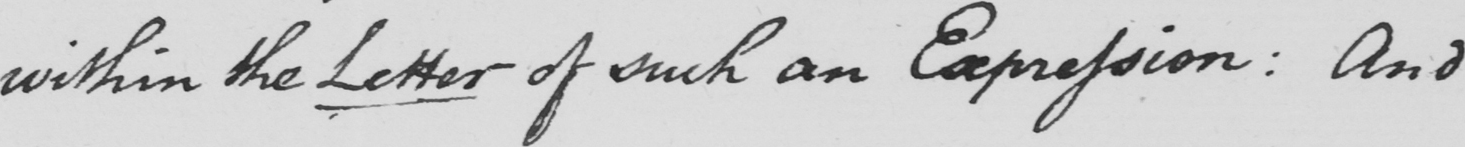Can you tell me what this handwritten text says? within the Letter of such an Expression :  And 